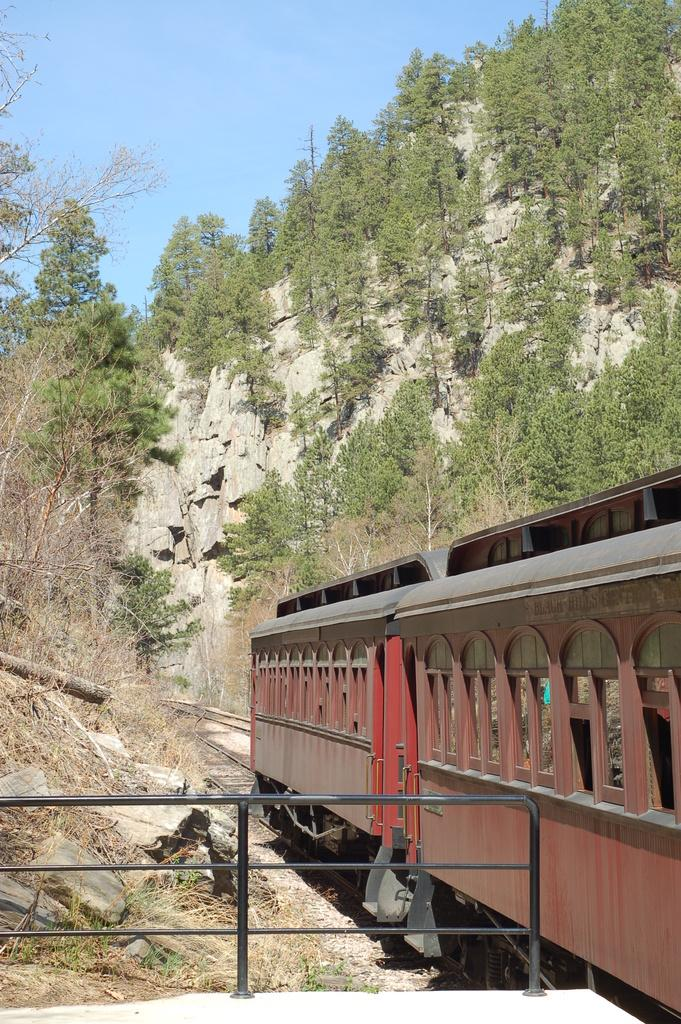What is the main subject of the image? The main subject of the image is a train. Where is the train located in the image? The train is on a railway track. What can be seen in the background of the image? There is a fence, trees, and the sky visible in the background of the image. How many kittens are playing on the train in the image? There are no kittens present in the image; it features a train on a railway track with a background of a fence, trees, and the sky. 